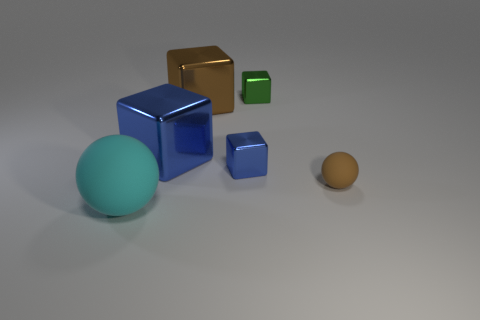Subtract all yellow cubes. Subtract all yellow cylinders. How many cubes are left? 4 Add 4 yellow shiny things. How many objects exist? 10 Subtract all blocks. How many objects are left? 2 Subtract 0 yellow cylinders. How many objects are left? 6 Subtract all blue metallic blocks. Subtract all brown matte objects. How many objects are left? 3 Add 4 shiny cubes. How many shiny cubes are left? 8 Add 1 green shiny things. How many green shiny things exist? 2 